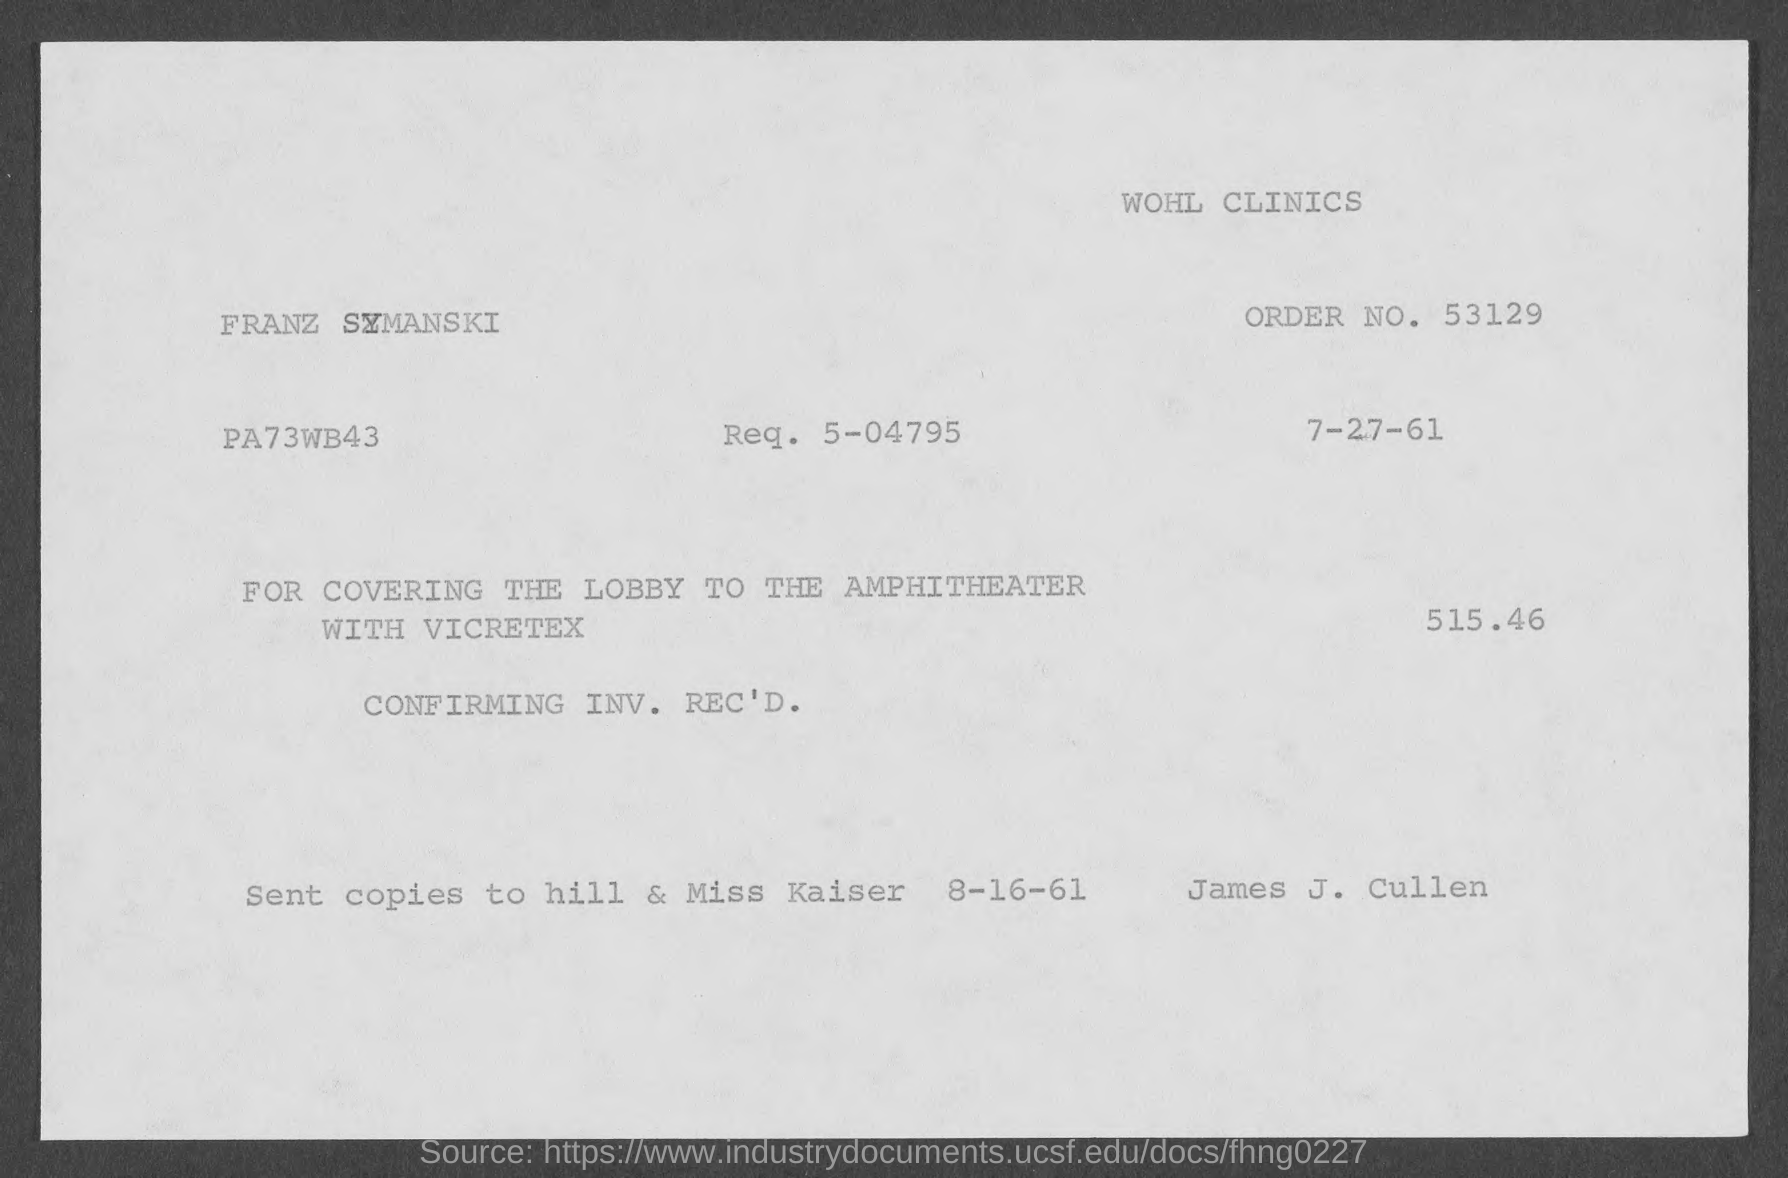What is the order no.?
Offer a terse response. 53129. What is the req. no?
Keep it short and to the point. 5-04795. 